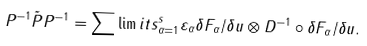<formula> <loc_0><loc_0><loc_500><loc_500>P ^ { - 1 } \tilde { P } P ^ { - 1 } = \sum \lim i t s _ { \alpha = 1 } ^ { s } \varepsilon _ { \alpha } \delta F _ { \alpha } / \delta u \otimes D ^ { - 1 } \circ \delta F _ { \alpha } / \delta u .</formula> 